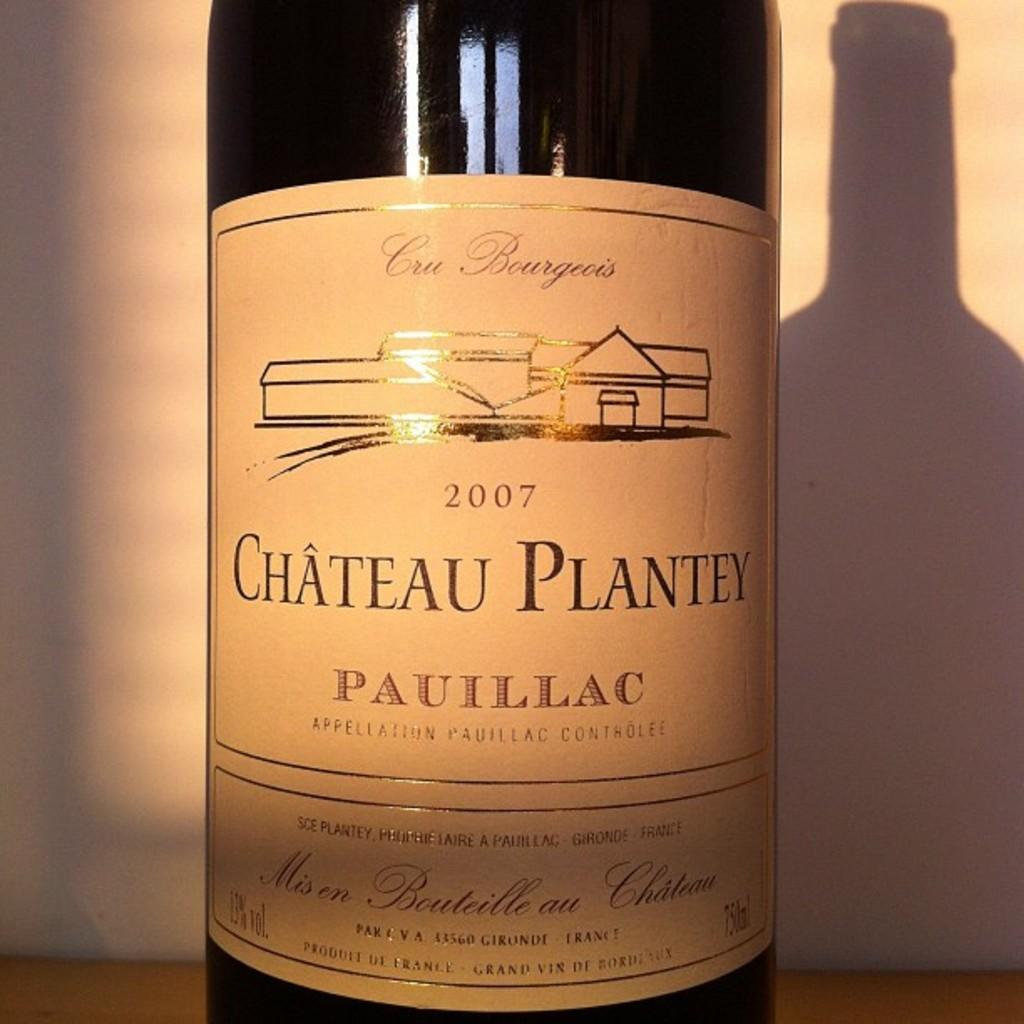<image>
Describe the image concisely. the word chateau plantey that is on a wine bottle 